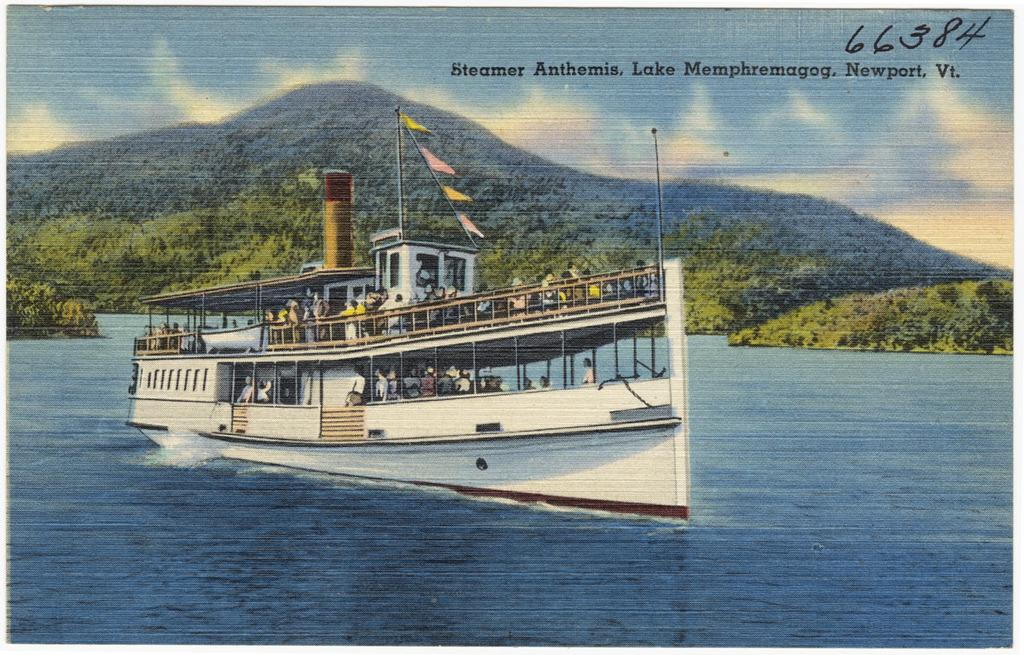What is the main subject of the image? There is a portrait in the image. What is depicted in the portrait? The portrait includes a big ship. Where is the ship located in the portrait? The ship is on the water. What other elements can be seen in the image? There are trees in the image. What type of locket is hanging from the trees in the image? There is no locket present in the image; it features a portrait of a big ship on the water and trees in the background. Can you describe the trousers worn by the trees in the image? Trees do not wear trousers, as they are not living beings capable of wearing clothing. 